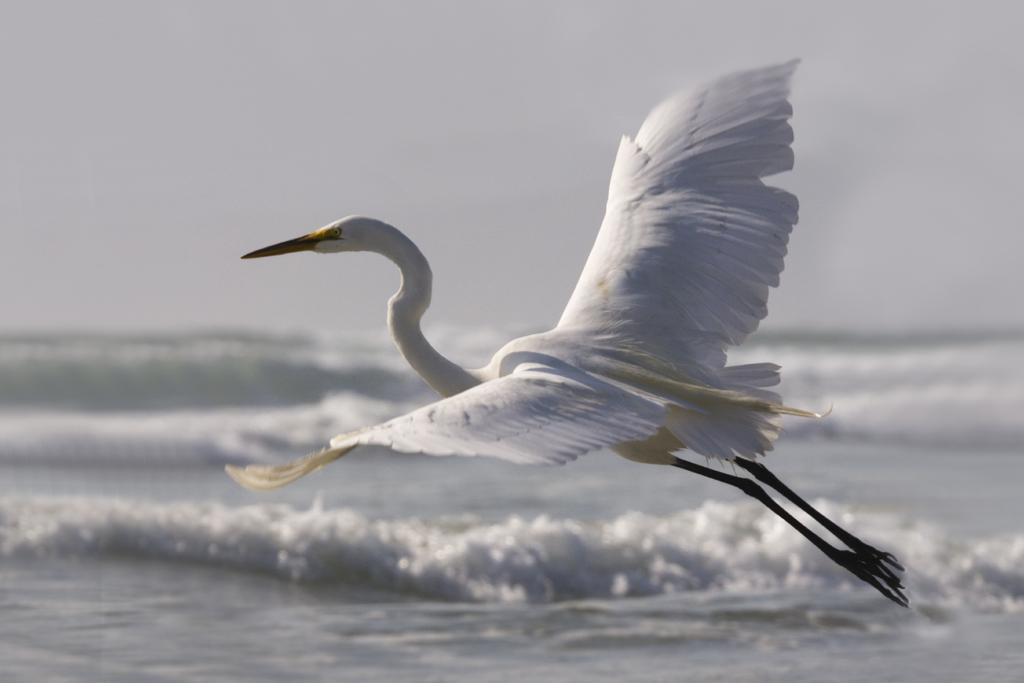What type of animal can be seen in the image? There is a bird in the image. What is the bird doing in the image? The bird is flying above the water surface. What type of stem can be seen in the image? There is no stem present in the image; it features a bird flying above the water surface. What is the profit margin of the band in the image? There is no band or profit margin mentioned in the image; it only shows a bird flying above the water surface. 